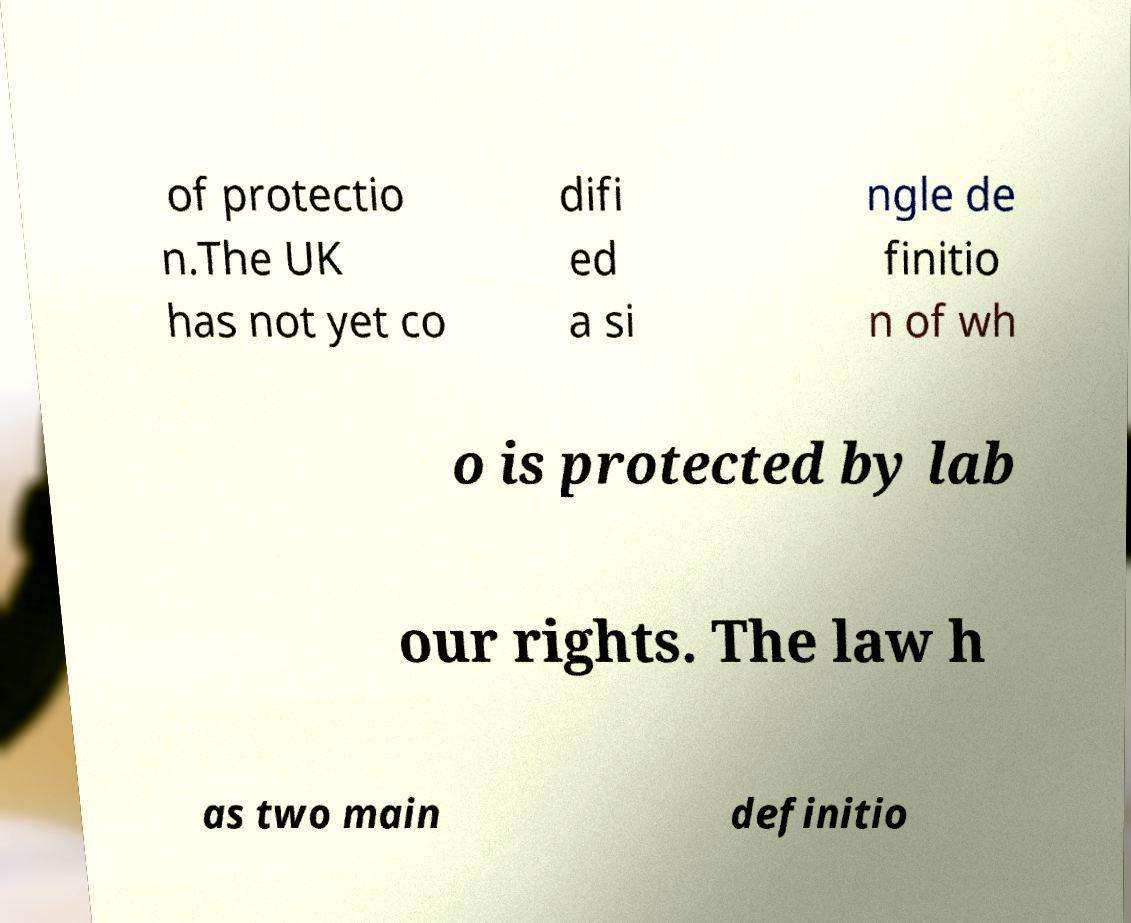Could you extract and type out the text from this image? of protectio n.The UK has not yet co difi ed a si ngle de finitio n of wh o is protected by lab our rights. The law h as two main definitio 